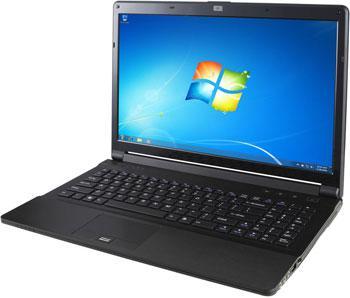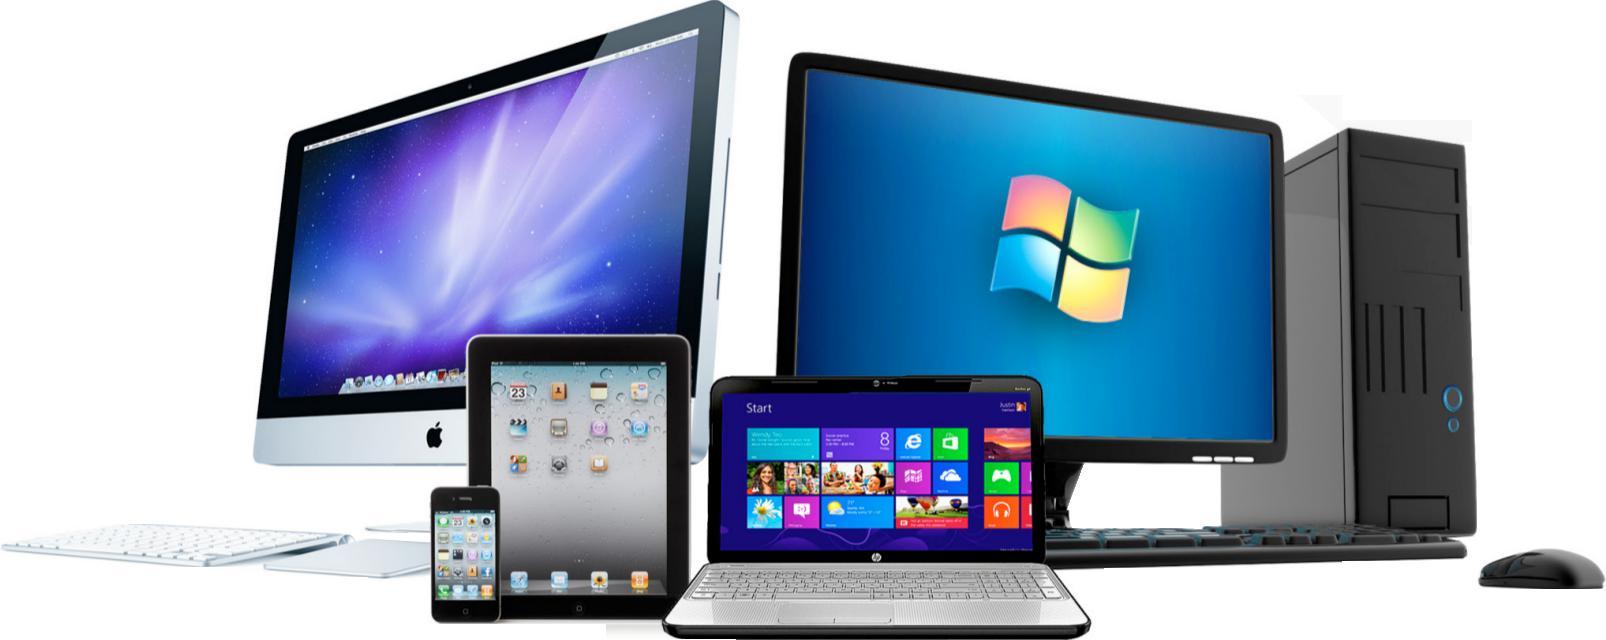The first image is the image on the left, the second image is the image on the right. Assess this claim about the two images: "One image shows a suite of devices on a plain background.". Correct or not? Answer yes or no. Yes. 